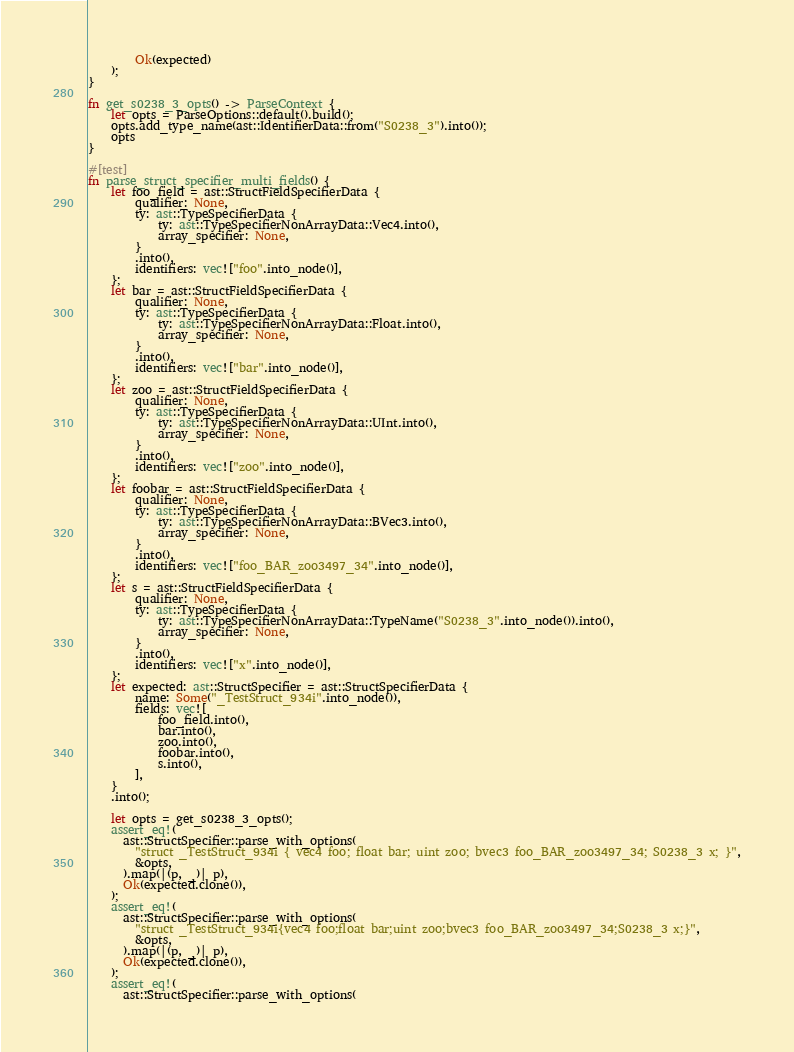<code> <loc_0><loc_0><loc_500><loc_500><_Rust_>        Ok(expected)
    );
}

fn get_s0238_3_opts() -> ParseContext {
    let opts = ParseOptions::default().build();
    opts.add_type_name(ast::IdentifierData::from("S0238_3").into());
    opts
}

#[test]
fn parse_struct_specifier_multi_fields() {
    let foo_field = ast::StructFieldSpecifierData {
        qualifier: None,
        ty: ast::TypeSpecifierData {
            ty: ast::TypeSpecifierNonArrayData::Vec4.into(),
            array_specifier: None,
        }
        .into(),
        identifiers: vec!["foo".into_node()],
    };
    let bar = ast::StructFieldSpecifierData {
        qualifier: None,
        ty: ast::TypeSpecifierData {
            ty: ast::TypeSpecifierNonArrayData::Float.into(),
            array_specifier: None,
        }
        .into(),
        identifiers: vec!["bar".into_node()],
    };
    let zoo = ast::StructFieldSpecifierData {
        qualifier: None,
        ty: ast::TypeSpecifierData {
            ty: ast::TypeSpecifierNonArrayData::UInt.into(),
            array_specifier: None,
        }
        .into(),
        identifiers: vec!["zoo".into_node()],
    };
    let foobar = ast::StructFieldSpecifierData {
        qualifier: None,
        ty: ast::TypeSpecifierData {
            ty: ast::TypeSpecifierNonArrayData::BVec3.into(),
            array_specifier: None,
        }
        .into(),
        identifiers: vec!["foo_BAR_zoo3497_34".into_node()],
    };
    let s = ast::StructFieldSpecifierData {
        qualifier: None,
        ty: ast::TypeSpecifierData {
            ty: ast::TypeSpecifierNonArrayData::TypeName("S0238_3".into_node()).into(),
            array_specifier: None,
        }
        .into(),
        identifiers: vec!["x".into_node()],
    };
    let expected: ast::StructSpecifier = ast::StructSpecifierData {
        name: Some("_TestStruct_934i".into_node()),
        fields: vec![
            foo_field.into(),
            bar.into(),
            zoo.into(),
            foobar.into(),
            s.into(),
        ],
    }
    .into();

    let opts = get_s0238_3_opts();
    assert_eq!(
      ast::StructSpecifier::parse_with_options(
        "struct _TestStruct_934i { vec4 foo; float bar; uint zoo; bvec3 foo_BAR_zoo3497_34; S0238_3 x; }",
        &opts,
      ).map(|(p, _)| p),
      Ok(expected.clone()),
    );
    assert_eq!(
      ast::StructSpecifier::parse_with_options(
        "struct _TestStruct_934i{vec4 foo;float bar;uint zoo;bvec3 foo_BAR_zoo3497_34;S0238_3 x;}",
        &opts,
      ).map(|(p, _)| p),
      Ok(expected.clone()),
    );
    assert_eq!(
      ast::StructSpecifier::parse_with_options(</code> 